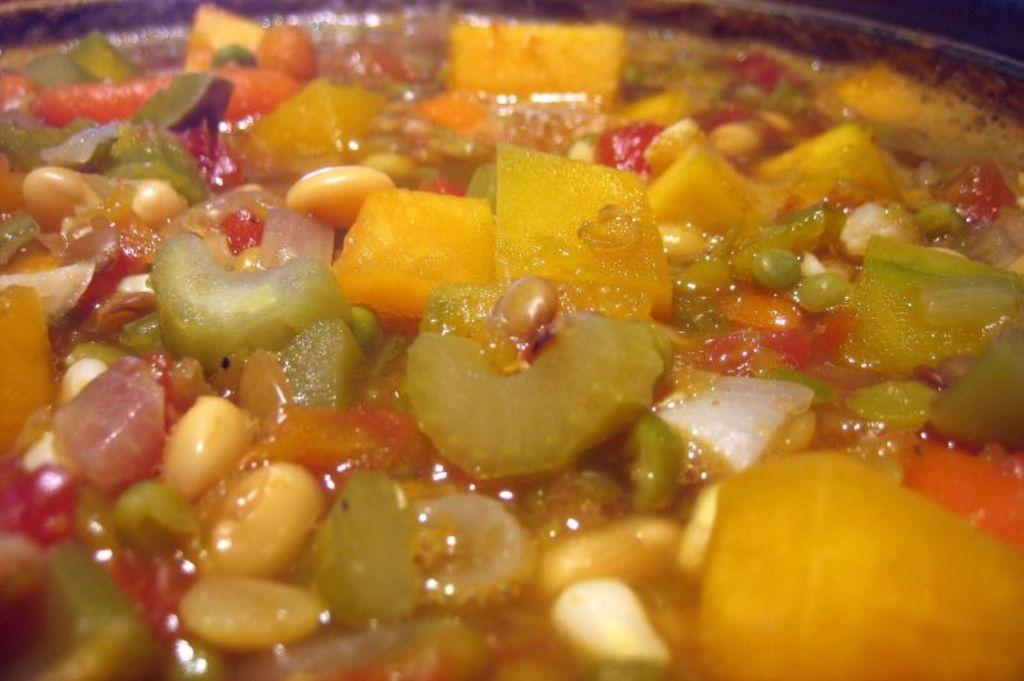What types of food can be seen on the plate in the image? There are nuts and vegetable pieces on the plate, as well as other food items. Can you describe the background of the image? The background of the image is dark in color. Is there a monkey climbing in the alley behind the plate of food in the image? No, there is no monkey or alley present in the image. 